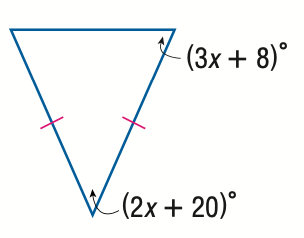Answer the mathemtical geometry problem and directly provide the correct option letter.
Question: Find x.
Choices: A: 12 B: 18 C: 18.9 D: 28 B 